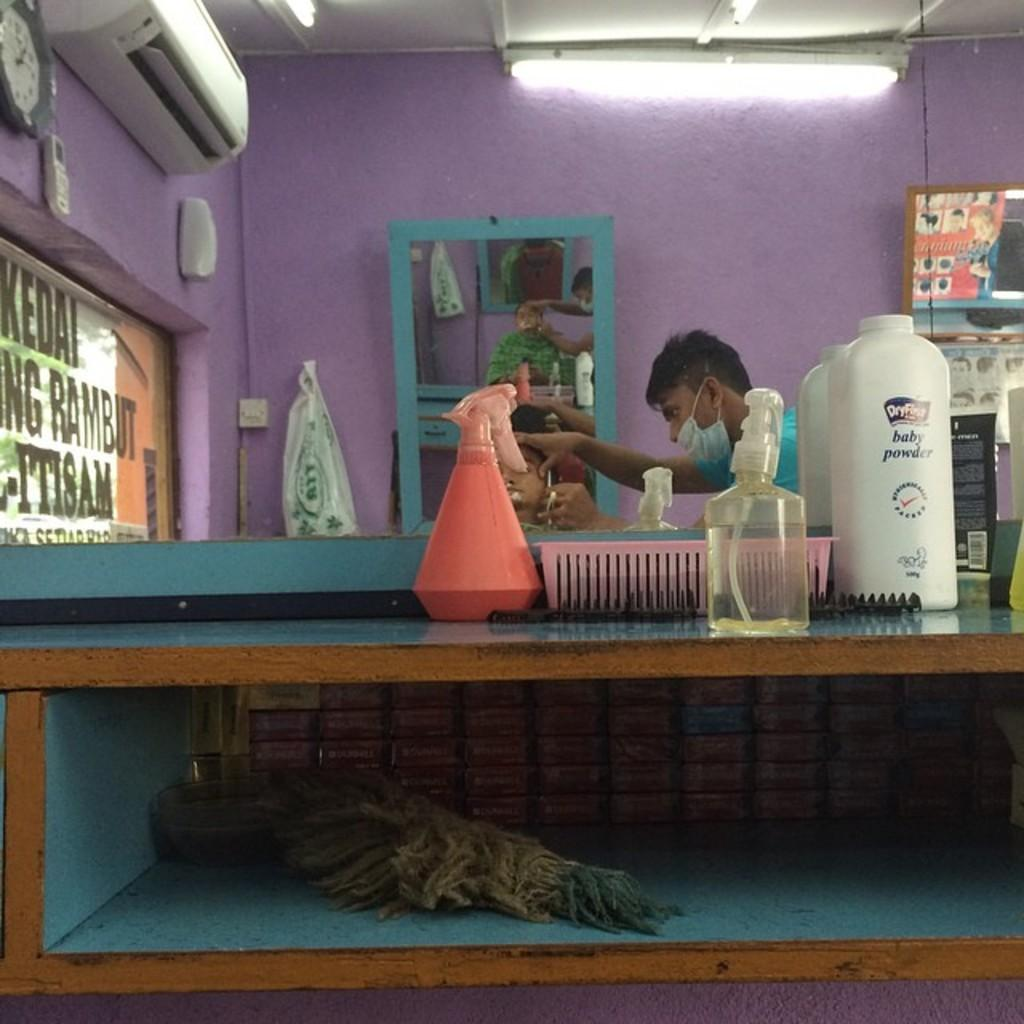What type of establishment is depicted in the image? There is a saloon in the image. What activity is taking place in the saloon? A man is shaving a customer in the saloon. What is used to help the customer see their appearance during the service? There is a mirror in the saloon. What items can be seen on a table in the saloon? There are bottles on a table in the saloon. What type of lunch is being served in the saloon? There is no lunch being served in the image; the focus is on the shaving service being provided. 